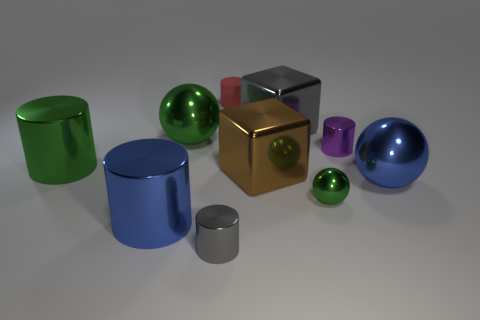What color is the small metal cylinder to the right of the small cylinder in front of the blue cylinder?
Offer a terse response. Purple. What number of large things are purple cylinders or objects?
Your answer should be compact. 6. How many large gray objects have the same material as the small gray object?
Your answer should be very brief. 1. There is a metallic sphere that is to the left of the matte cylinder; what size is it?
Ensure brevity in your answer.  Large. The green object that is in front of the large blue thing on the right side of the brown metallic object is what shape?
Offer a very short reply. Sphere. What number of purple metal objects are behind the large brown object on the left side of the blue object right of the rubber cylinder?
Offer a very short reply. 1. Is the number of green metallic cylinders that are behind the big gray shiny block less than the number of big red shiny things?
Provide a short and direct response. No. Is there any other thing that is the same shape as the big gray thing?
Give a very brief answer. Yes. What is the shape of the green metal object right of the tiny rubber cylinder?
Make the answer very short. Sphere. What is the shape of the metallic object that is in front of the large metal cylinder that is in front of the green metal sphere in front of the purple thing?
Give a very brief answer. Cylinder. 